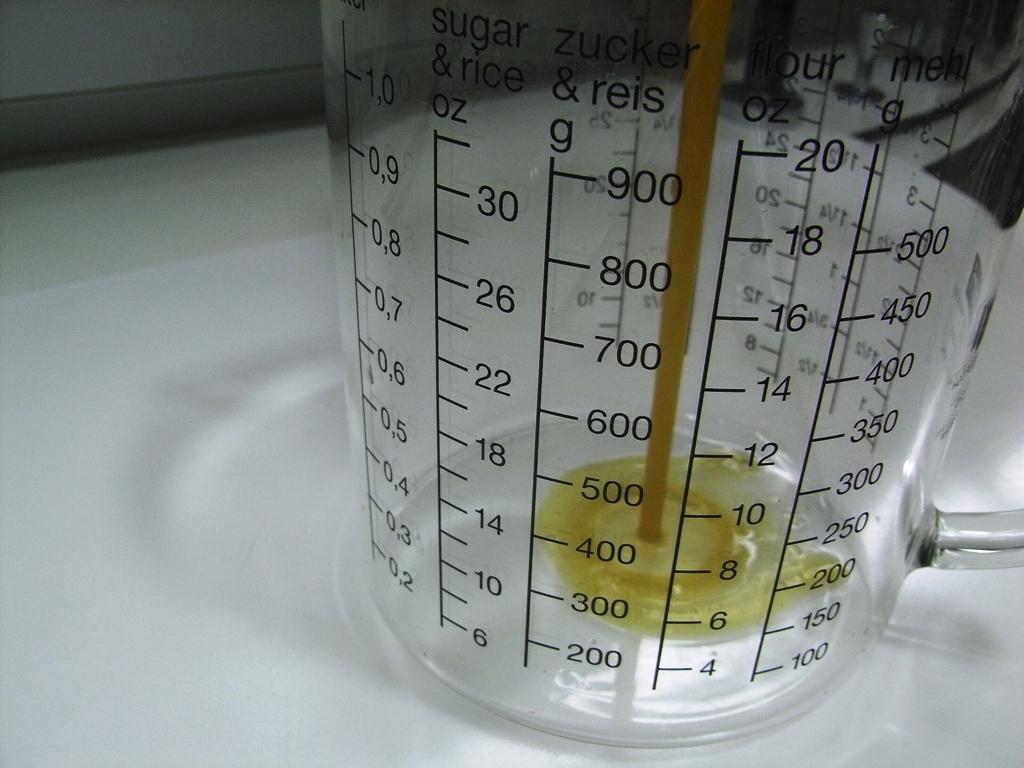Does it measure sugar and rice in ounces?
Your answer should be very brief. Yes. 